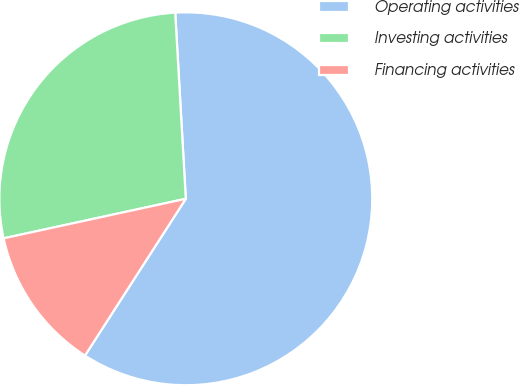Convert chart. <chart><loc_0><loc_0><loc_500><loc_500><pie_chart><fcel>Operating activities<fcel>Investing activities<fcel>Financing activities<nl><fcel>60.0%<fcel>27.5%<fcel>12.5%<nl></chart> 